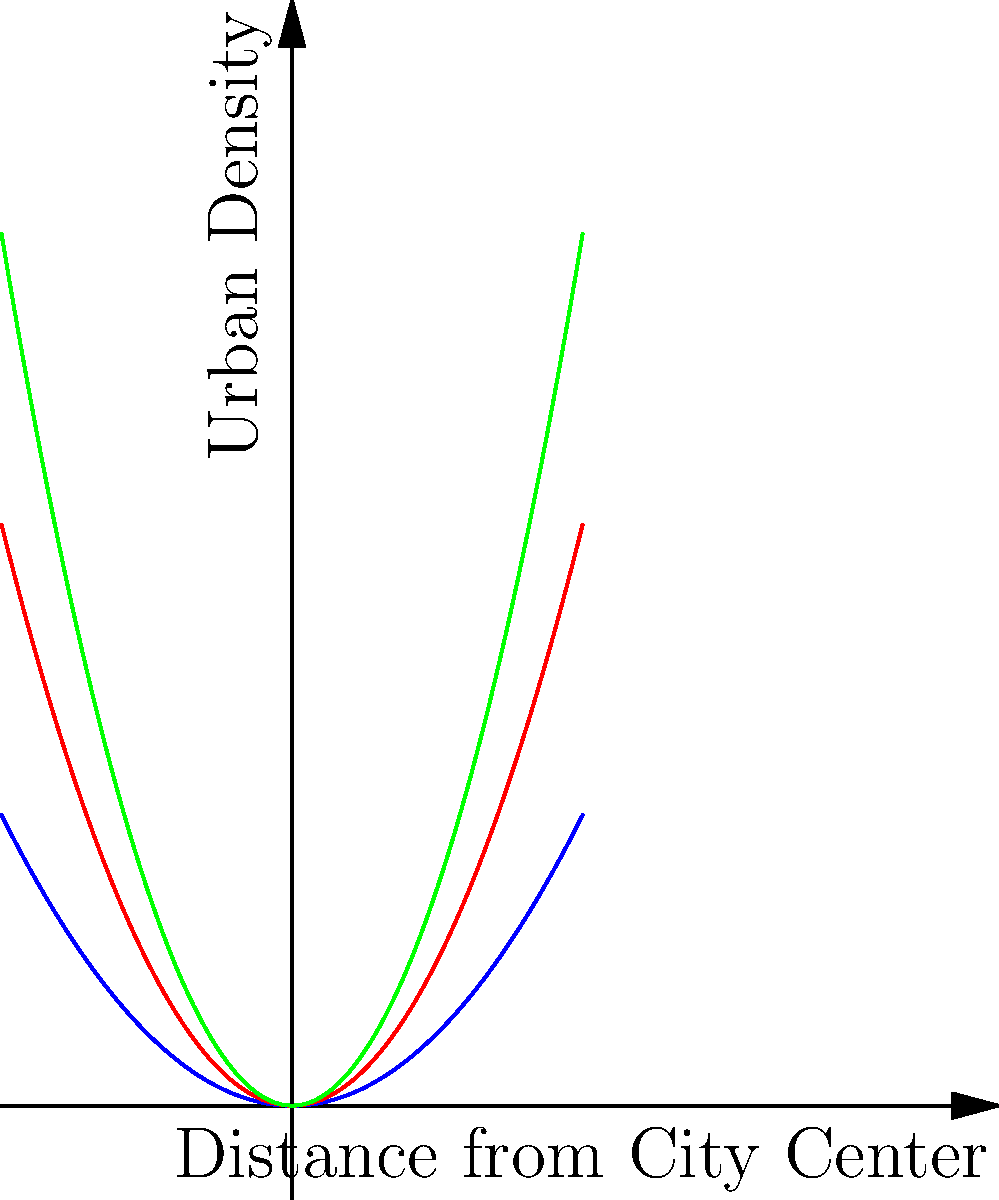Analyze the graph showing urban density patterns over time. Which year exhibits the most rapid increase in urban density as distance from the city center increases? To determine which year shows the steepest increase in urban density with distance from the city center:

1. Observe the three curves representing different years (1990, 2000, 2010).
2. Compare the steepness of each curve:
   - 1990 (blue): least steep
   - 2000 (red): steeper than 1990
   - 2010 (green): steepest of all
3. The steepest curve indicates the most rapid increase in urban density.
4. The green curve (2010) has the steepest slope, showing the fastest increase in urban density as distance from the city center increases.

Therefore, 2010 exhibits the most rapid increase in urban density as distance from the city center increases.
Answer: 2010 